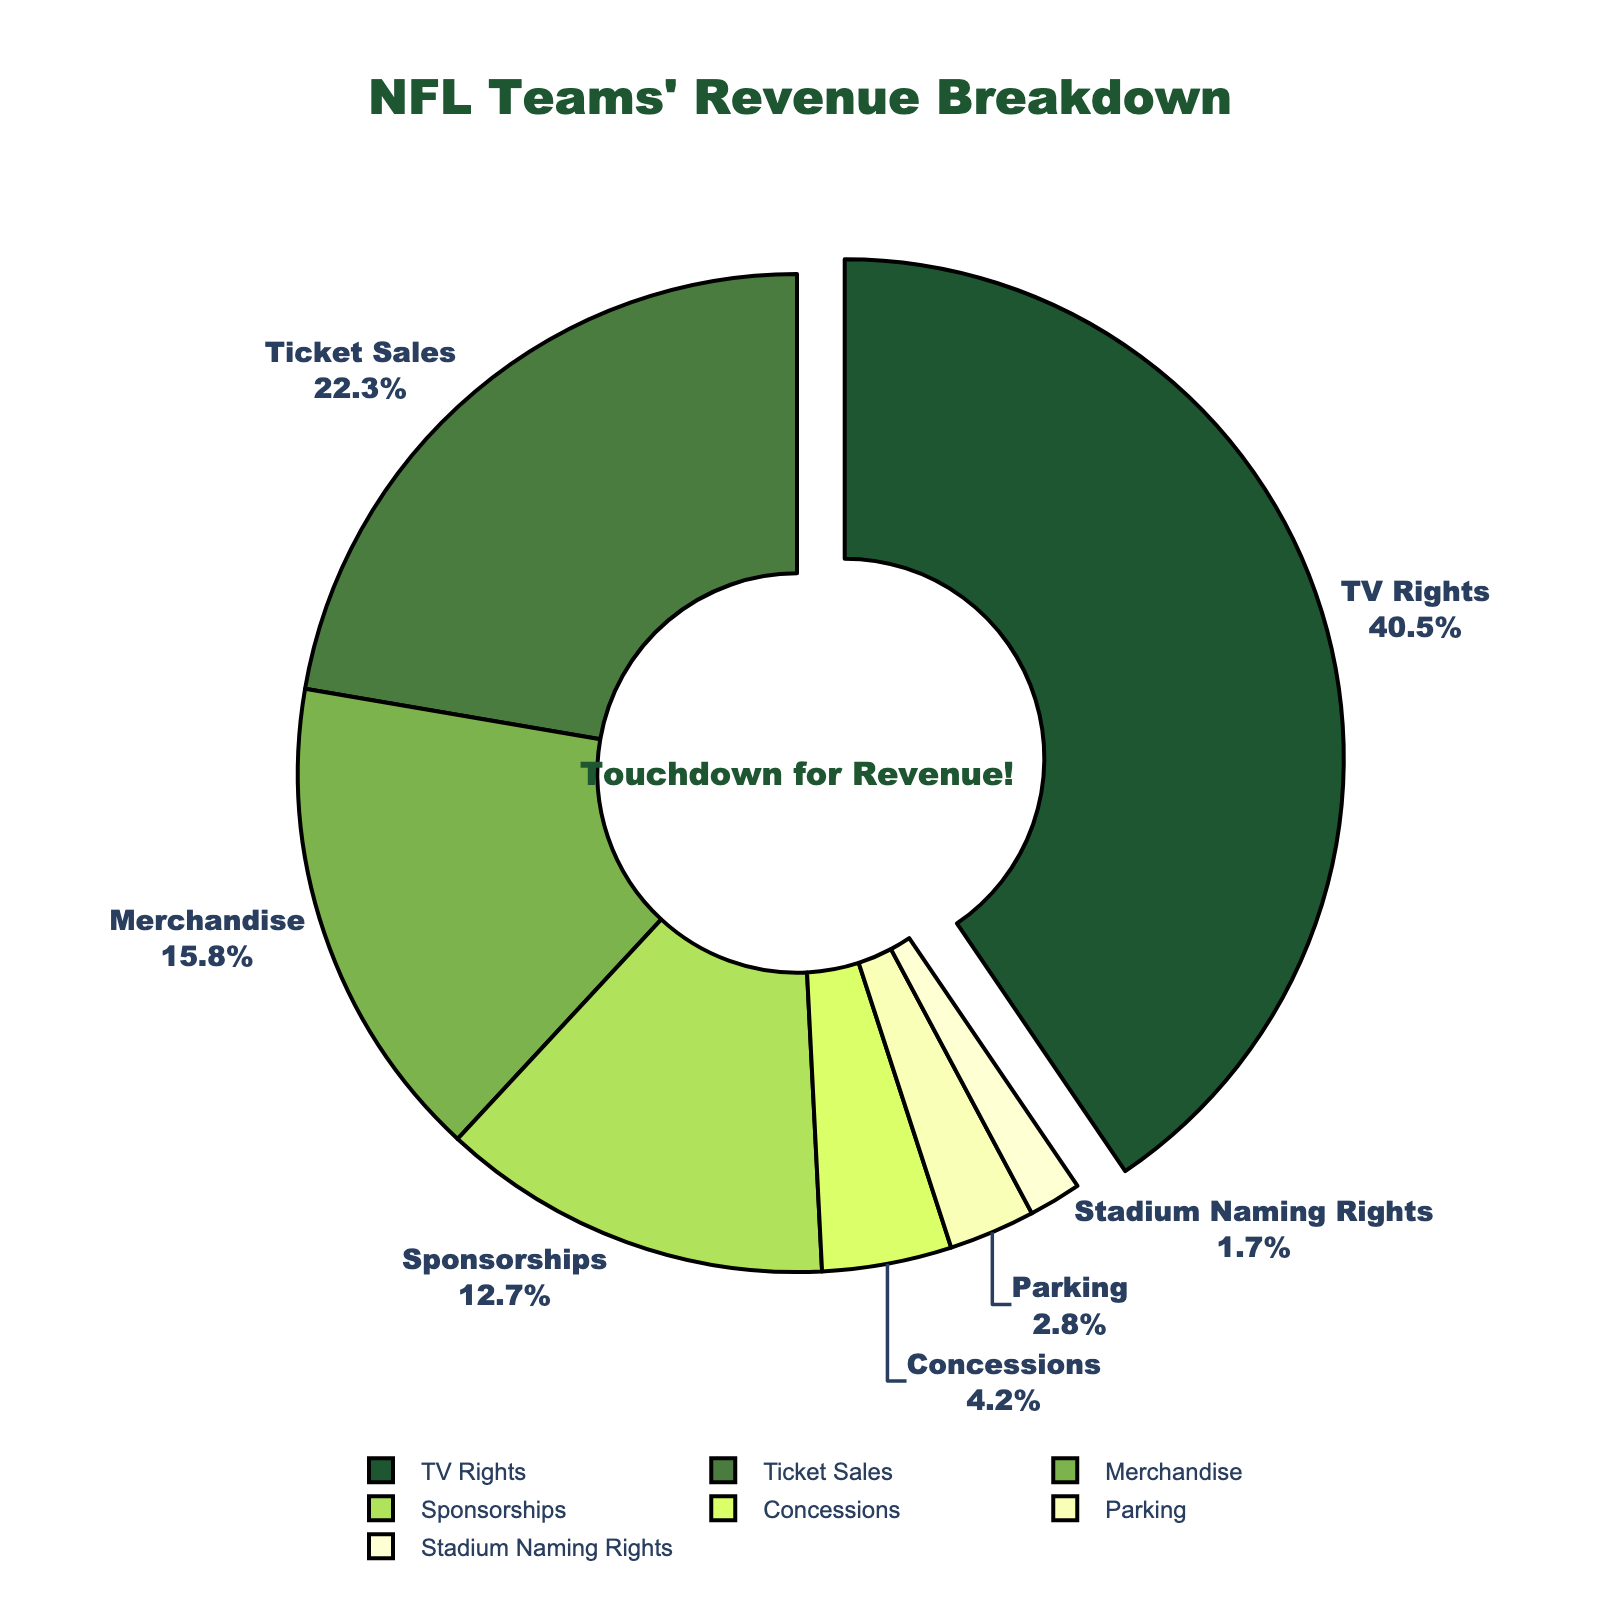what is the percentage of revenue from TV Rights and Ticket Sales combined? To find the combined percentage of revenue from TV Rights and Ticket Sales, we add the individual percentages: 40.5% (TV Rights) + 22.3% (Ticket Sales) = 62.8%
Answer: 62.8% which revenue source contributes the least to the total revenue of the NFL teams? The revenue source with the smallest percentage in the figure is Stadium Naming Rights with 1.7%.
Answer: Stadium Naming Rights how much more revenue is generated from TV Rights compared to Merchandise? The difference in revenue percentage between TV Rights and Merchandise is calculated by subtracting the percentage of Merchandise (15.8%) from the percentage of TV Rights (40.5%): 40.5% - 15.8% = 24.7%
Answer: 24.7% which category stands out visually with a different design from the rest in the pie chart? The category with a different design is TV Rights, which is pulled out from the pie chart to highlight its significance.
Answer: TV Rights what is the combined percentage of revenue from Sponsorships, Concessions, Parking, and Stadium Naming Rights? To find the combined percentage of revenue from these categories, we add the individual percentages: 12.7% (Sponsorships) + 4.2% (Concessions) + 2.8% (Parking) + 1.7% (Stadium Naming Rights) = 21.4%
Answer: 21.4% 